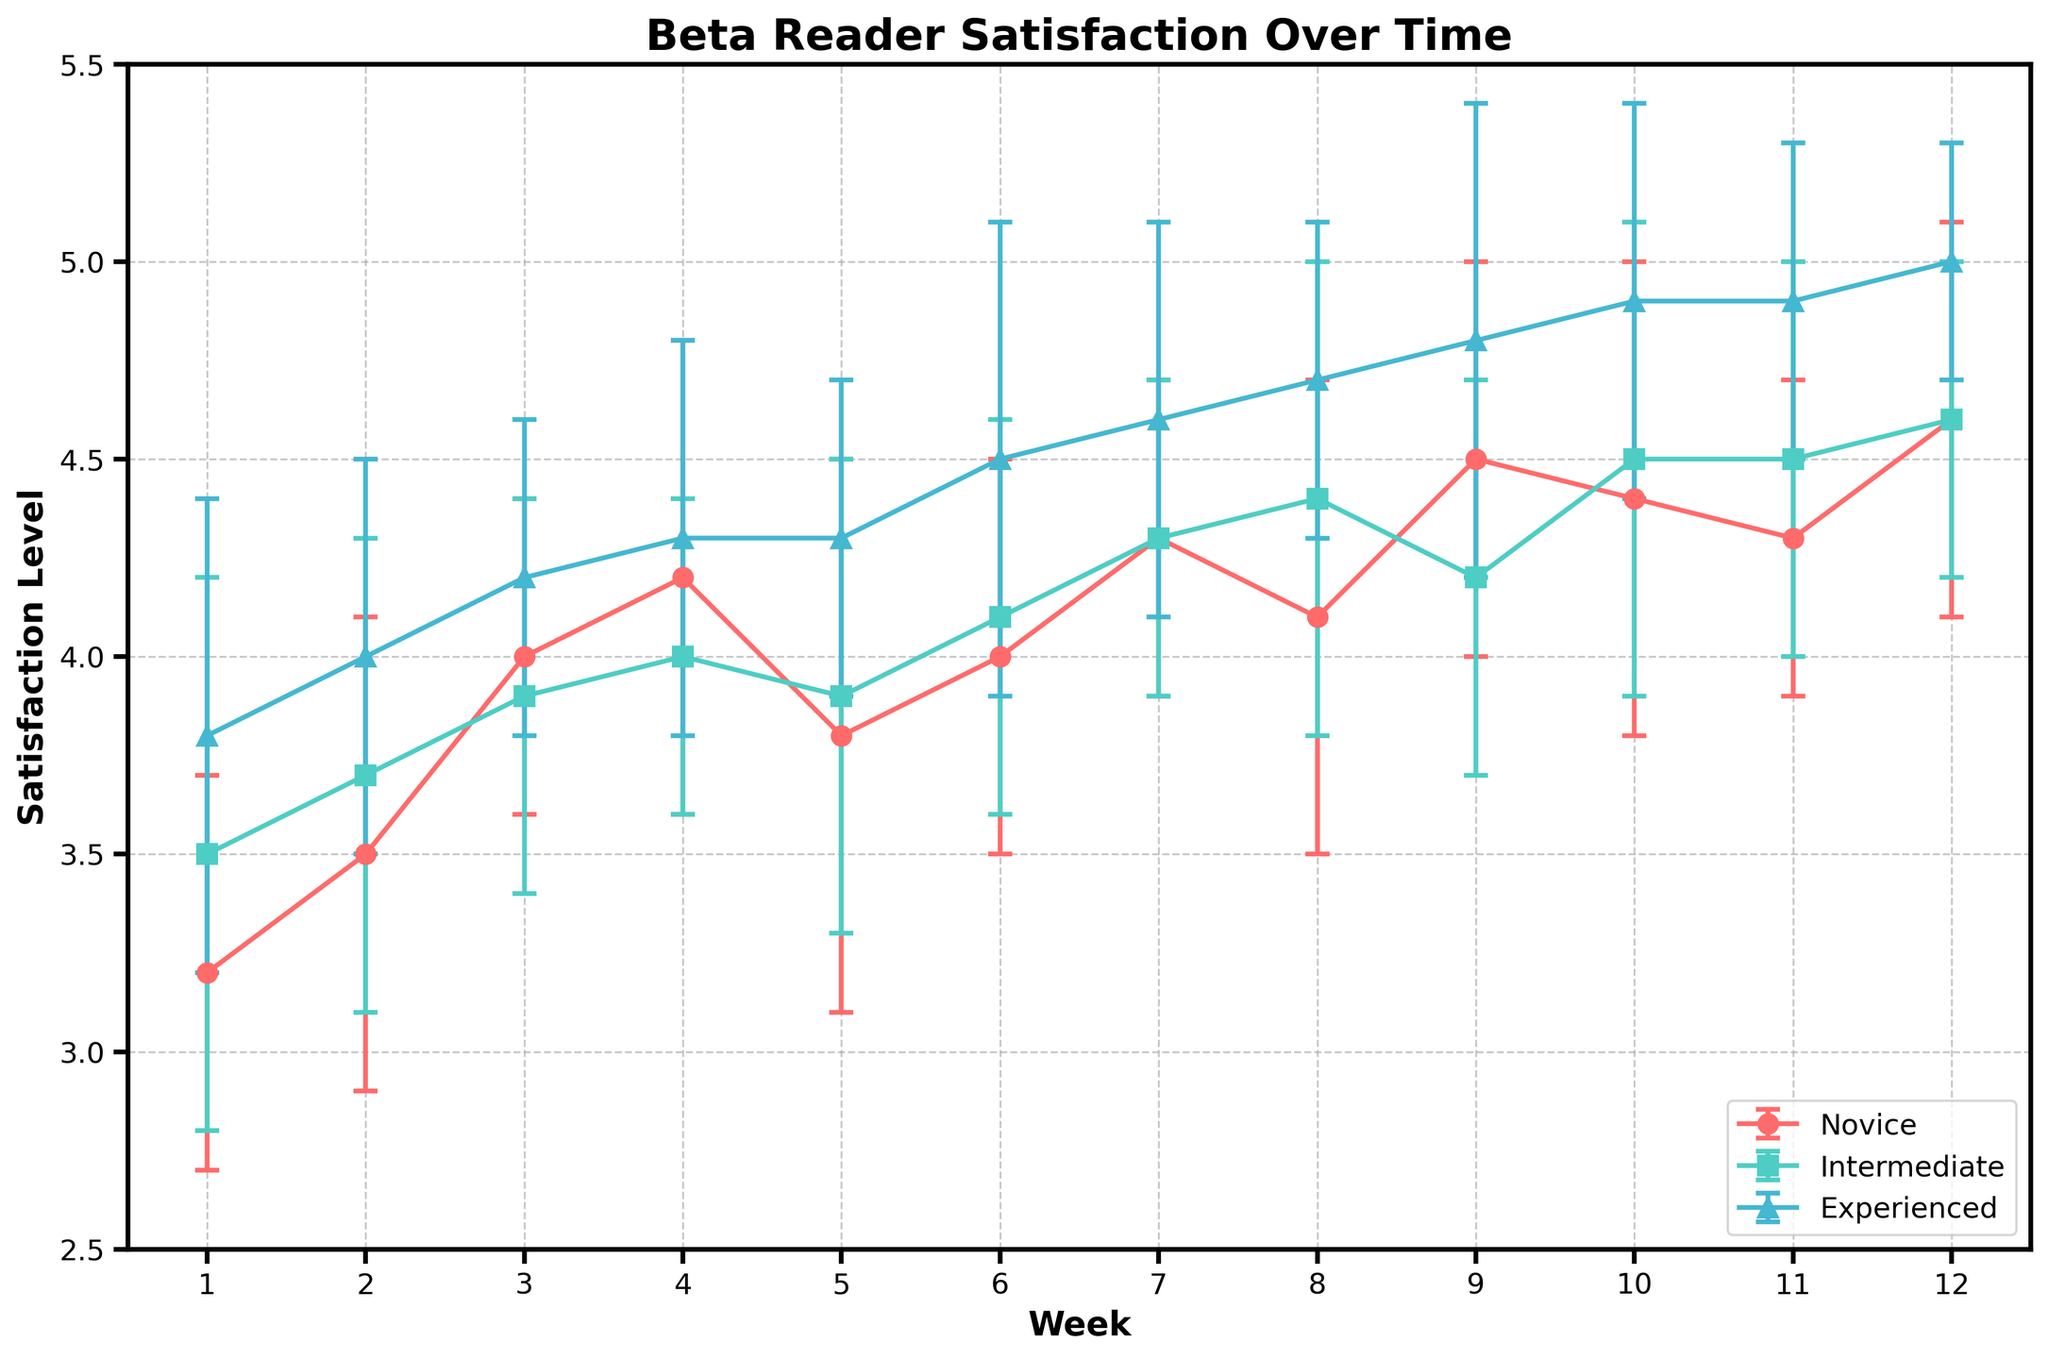What is the title of the plot? Look at the top of the figure where the title is displayed in bold text.
Answer: Beta Reader Satisfaction Over Time What is the x-axis label? The x-axis label is written in bold text below the x-axis line.
Answer: Week What is the mean satisfaction level for experienced beta readers in Week 12? Find the point or line segment for experienced beta readers (usually depicted using markers or lines specific to that category). Then, locate Week 12 on the x-axis and read the corresponding y-value for experienced readers.
Answer: 5.0 What week shows the highest standard deviation for novice beta readers? Look for the points or line segments with error bars that represent novice beta readers. The week with the largest error bars signifies the highest standard deviation.
Answer: Week 5 Which beta reader experience level has the highest mean satisfaction level in Week 6? Identify the data points for Week 6 across novice, intermediate, and experienced beta readers by looking at the respective markers. Compare the y-values (mean satisfaction levels) and find the highest one.
Answer: Experienced Between Week 4 and Week 6, did satisfaction levels for novice beta readers increase or decrease? Check the points or segments for novice beta readers at Week 4 and Week 6. Observe the change in y-values (satisfaction levels) between these weeks.
Answer: Increase What is the trend in satisfaction levels for intermediate beta readers from Week 1 to Week 12? Locate the series of data points or segments for intermediate beta readers. Observe the overall movement of these points along the y-axis from Week 1 to Week 12.
Answer: Increasing Which experience level had the most consistent satisfaction levels over the 12-week period? Determine the consistency by evaluating the lengths of the error bars for each experience level over the 12 weeks. The level with the shortest error bars overall is the most consistent.
Answer: Experienced What is the difference in satisfaction levels between novice and experienced beta readers in Week 8? Find the satisfaction levels for novice and experienced beta readers in Week 8 and take the difference between these values.
Answer: 0.6 By how much did the mean satisfaction level for intermediate beta readers increase from Week 1 to Week 12? Note the mean satisfaction level for intermediate beta readers at Week 1 and Week 12, and calculate the difference between these values.
Answer: 1.1 